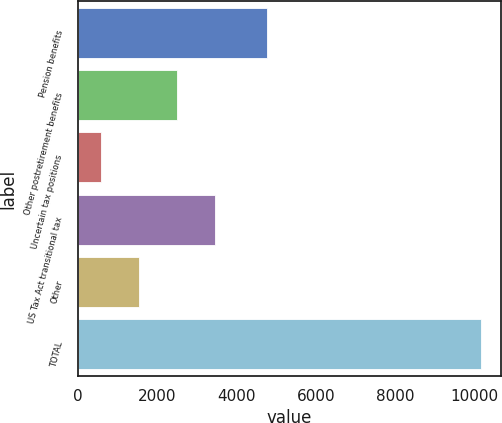<chart> <loc_0><loc_0><loc_500><loc_500><bar_chart><fcel>Pension benefits<fcel>Other postretirement benefits<fcel>Uncertain tax positions<fcel>US Tax Act transitional tax<fcel>Other<fcel>TOTAL<nl><fcel>4768<fcel>2497.6<fcel>581<fcel>3455.9<fcel>1539.3<fcel>10164<nl></chart> 